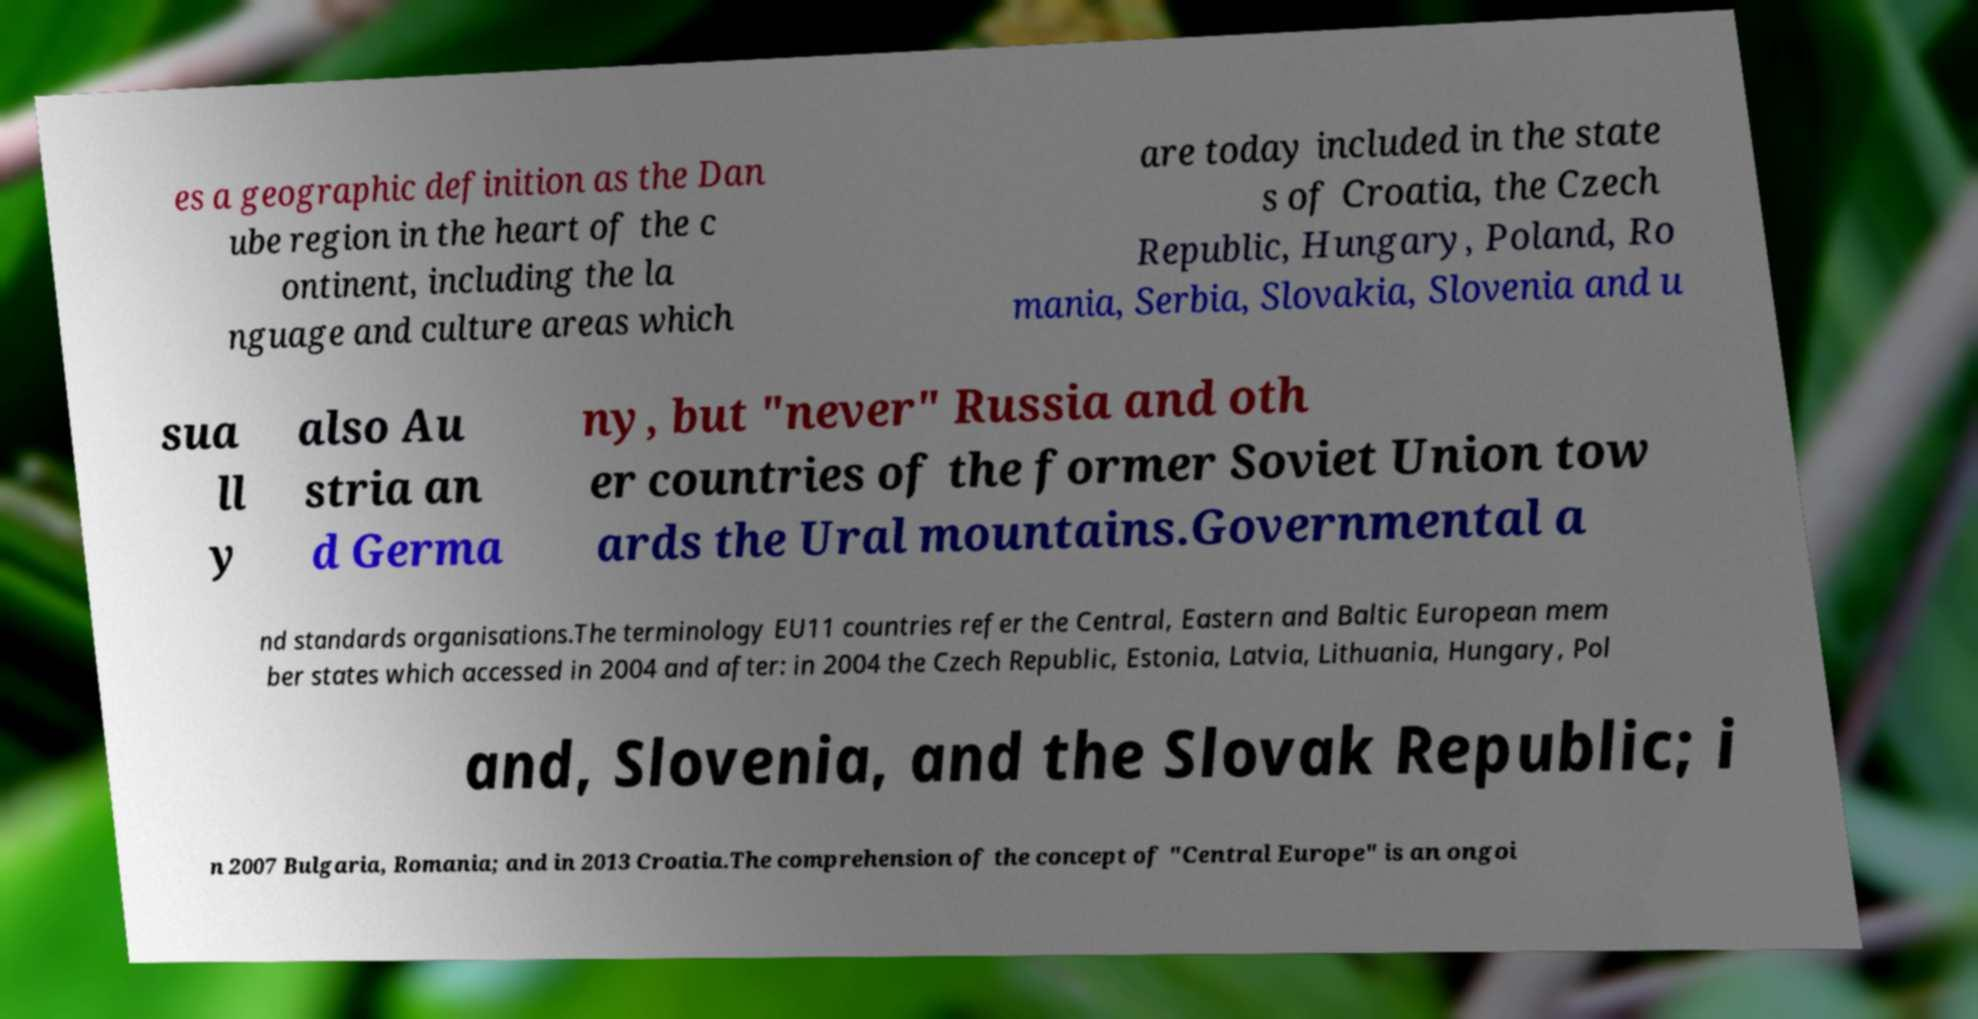There's text embedded in this image that I need extracted. Can you transcribe it verbatim? es a geographic definition as the Dan ube region in the heart of the c ontinent, including the la nguage and culture areas which are today included in the state s of Croatia, the Czech Republic, Hungary, Poland, Ro mania, Serbia, Slovakia, Slovenia and u sua ll y also Au stria an d Germa ny, but "never" Russia and oth er countries of the former Soviet Union tow ards the Ural mountains.Governmental a nd standards organisations.The terminology EU11 countries refer the Central, Eastern and Baltic European mem ber states which accessed in 2004 and after: in 2004 the Czech Republic, Estonia, Latvia, Lithuania, Hungary, Pol and, Slovenia, and the Slovak Republic; i n 2007 Bulgaria, Romania; and in 2013 Croatia.The comprehension of the concept of "Central Europe" is an ongoi 